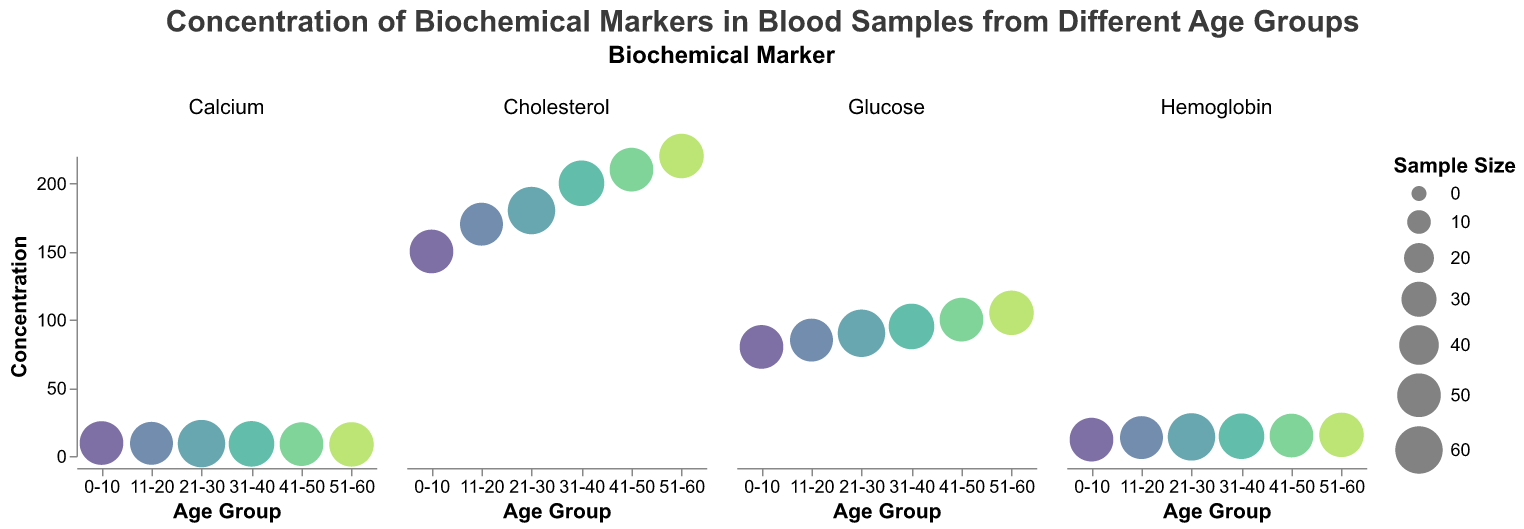What is the title of the figure? The title is displayed at the top of the chart in a large font.
Answer: Concentration of Biochemical Markers in Blood Samples from Different Age Groups Which age group has the highest concentration of glucose? By examining the glucose subplot, the highest concentration of glucose is at age group 51-60.
Answer: 51-60 What are the concentration levels of cholesterol across all age groups? Observing the cholesterol subplot, the concentration levels are: 0-10 (150), 11-20 (170), 21-30 (180), 31-40 (200), 41-50 (210), 51-60 (220).
Answer: 150, 170, 180, 200, 210, 220 What is the trend of hemoglobin concentration with increasing age groups? Examining the subplot for hemoglobin, the concentration increases with age groups: 0-10 (12), 11-20 (13.5), 21-30 (14), 31-40 (14.5), 41-50 (15), 51-60 (15.5).
Answer: Increasing Which age group has the largest sample size for calcium concentration? By looking at the bubble sizes in the calcium subplot, the largest sample size is in the 21-30 age group.
Answer: 21-30 What are the concentrations of glucose for the 31-40 age group? On the glucose subplot, locate the bubble corresponding to "31-40", which shows a concentration of 95.
Answer: 95 How does the concentration of calcium change from age group 0-10 to 51-60? Observing the subplot for calcium, the concentration levels are: 0-10 (9.5), 11-20 (9.3), 21-30 (9.1), 31-40 (8.9), 41-50 (8.7), 51-60 (8.5). The concentration decreases across these age groups.
Answer: Decreasing Which biochemical marker shows the steadiest concentration across the age groups? By examining each subplot, hemoglobin shows a steady increase, while other markers present more fluctuations.
Answer: Hemoglobin Are cholesterol concentrations higher in older age groups? By comparing the bubbles in the cholesterol subplot, older age groups (41-50 and 51-60) have higher concentrations, up to 210 and 220 respectively.
Answer: Yes What is the average concentration of glucose across all age groups? To find the average glucose concentration, sum the values: 80 + 85 + 90 + 95 + 100 + 105 = 555. Divide by the number of age groups (6): 555 / 6 = 92.5.
Answer: 92.5 